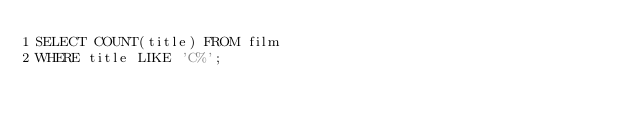Convert code to text. <code><loc_0><loc_0><loc_500><loc_500><_SQL_>SELECT COUNT(title) FROM film
WHERE title LIKE 'C%';</code> 